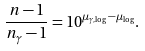<formula> <loc_0><loc_0><loc_500><loc_500>\frac { n - 1 } { n _ { \gamma } - 1 } = 1 0 ^ { \mu _ { \gamma , \log } - \mu _ { \log } } .</formula> 